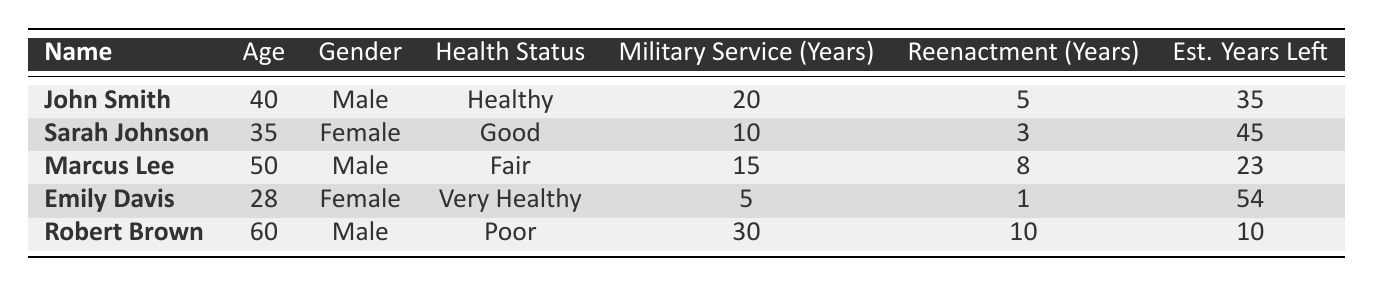What is the expected life expectancy for Sarah Johnson? The table lists the expected life expectancy for each individual. For Sarah Johnson, it states "80" under the column "Expected Life Expectancy Right Now."
Answer: 80 How many years of military service does Robert Brown have? According to the table, under the column "Military Service (Years)", Robert Brown has "30" years of military service.
Answer: 30 What is the average estimated years left for all individuals listed? To calculate the average, sum the estimated years left for all individuals which are (35 + 45 + 23 + 54 + 10) = 167. Then divide by the number of individuals, which is 5. Thus, 167/5 = 33.4.
Answer: 33.4 Is Emily Davis healthier than Marcus Lee? The health status of Emily Davis is "Very Healthy" while that of Marcus Lee is "Fair." Since "Very Healthy" is a higher status than "Fair," the answer is yes.
Answer: Yes Who has the least estimated years left, and how many are they? Reviewing the "Est. Years Left" column, Robert Brown has the least at "10" years left. The others have more.
Answer: Robert Brown, 10 What is the total weight of all individuals listed? To find the total weight, add the weights: (75 + 60 + 85 + 55 + 95) = 370 kg.
Answer: 370 kg Which gender has the highest average expected life expectancy? Calculate the average for each gender: For males, (75 + 73 + 70) / 3 = 72.67; for females, (80 + 82) / 2 = 81. The average expected life expectancy is higher for females.
Answer: Female If you combine the reenactment years of all individuals, what is the total? Sum the reenactment years: (5 + 3 + 8 + 1 + 10) = 27 years of reenactment in total.
Answer: 27 Does John Smith have more military service years than the average of the group? Calculate the average military service years: (20 + 10 + 15 + 5 + 30) / 5 = 16. John's 20 years exceeds this average, so the answer is yes.
Answer: Yes 